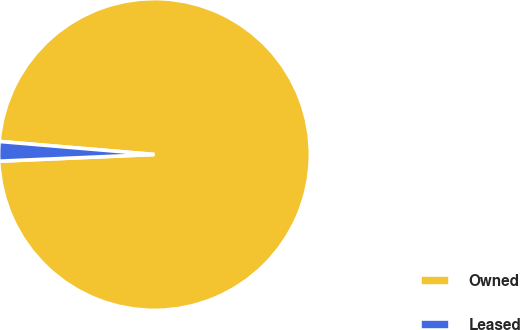Convert chart. <chart><loc_0><loc_0><loc_500><loc_500><pie_chart><fcel>Owned<fcel>Leased<nl><fcel>97.98%<fcel>2.02%<nl></chart> 